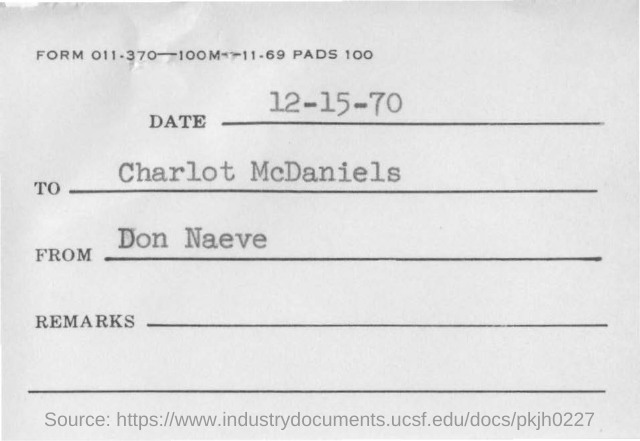Mention a couple of crucial points in this snapshot. The recipient of the message is Charlotte McDaniels. The top of the document contains the text 'FORM 011.370-100M-11.69 PADS 100..' The document contains a date of December 15, 1970. 